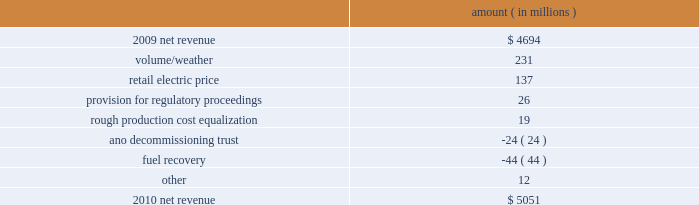Entergy corporation and subsidiaries management's financial discussion and analysis refer to 201cselected financial data - five-year comparison of entergy corporation and subsidiaries 201d which accompanies entergy corporation 2019s financial statements in this report for further information with respect to operating statistics .
In november 2007 the board approved a plan to pursue a separation of entergy 2019s non-utility nuclear business from entergy through a spin-off of the business to entergy shareholders .
In april 2010 , entergy announced that it planned to unwind the business infrastructure associated with the proposed spin-off transaction .
As a result of the plan to unwind the business infrastructure , entergy recorded expenses in 2010 for the write-off of certain capitalized costs incurred in connection with the planned spin-off transaction .
These costs are discussed in more detail below and throughout this section .
Net revenue utility following is an analysis of the change in net revenue comparing 2010 to 2009 .
Amount ( in millions ) .
The volume/weather variance is primarily due to an increase of 8362 gwh , or 8% ( 8 % ) , in billed electricity usage in all retail sectors , including the effect on the residential sector of colder weather in the first quarter 2010 compared to 2009 and warmer weather in the second and third quarters 2010 compared to 2009 .
The industrial sector reflected strong sales growth on continuing signs of economic recovery .
The improvement in this sector was primarily driven by inventory restocking and strong exports with the chemicals , refining , and miscellaneous manufacturing sectors leading the improvement .
The retail electric price variance is primarily due to : increases in the formula rate plan riders at entergy gulf states louisiana effective november 2009 , january 2010 , and september 2010 , at entergy louisiana effective november 2009 , and at entergy mississippi effective july 2009 ; a base rate increase at entergy arkansas effective july 2010 ; rate actions at entergy texas , including base rate increases effective in may and august 2010 ; a formula rate plan provision of $ 16.6 million recorded in the third quarter 2009 for refunds that were made to customers in accordance with settlements approved by the lpsc ; and the recovery in 2009 by entergy arkansas of 2008 extraordinary storm costs , as approved by the apsc , which ceased in january 2010 .
The recovery of storm costs is offset in other operation and maintenance expenses .
See note 2 to the financial statements for further discussion of the proceedings referred to above. .
What portion of the net change in net revenue is due to the retail electric price? 
Computations: (137 / (5051 - 4694))
Answer: 0.38375. 